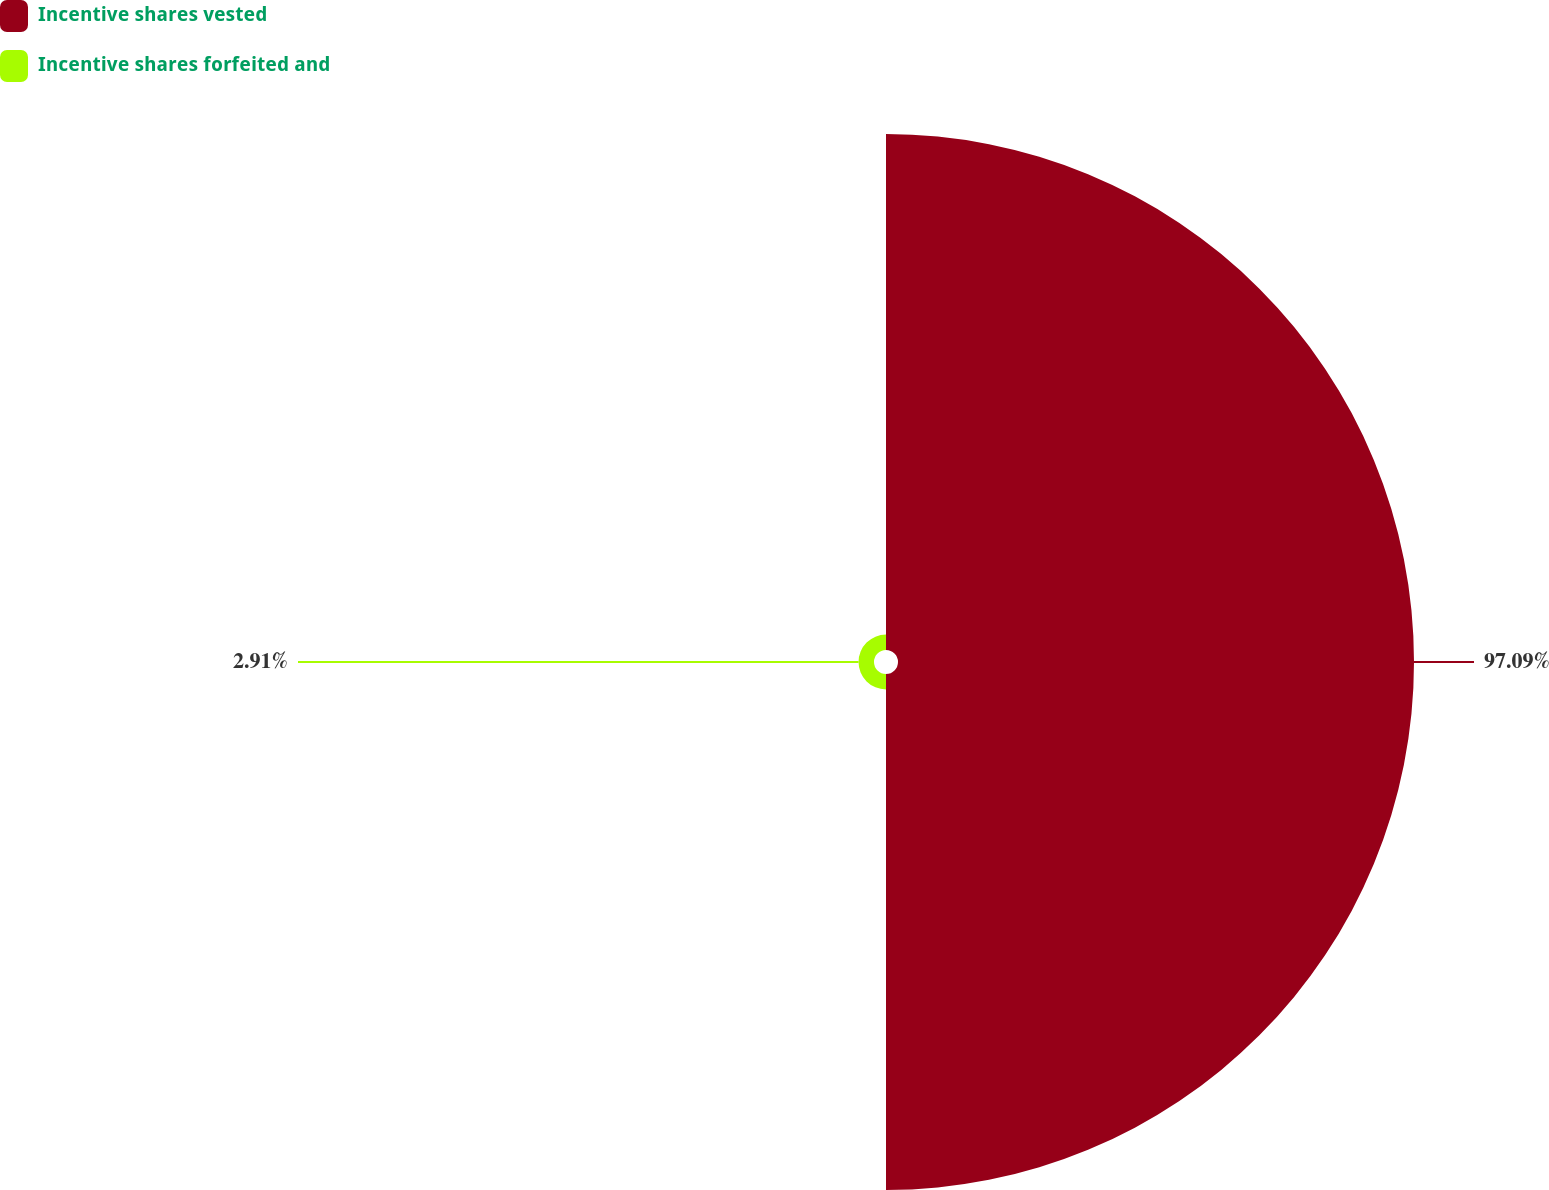<chart> <loc_0><loc_0><loc_500><loc_500><pie_chart><fcel>Incentive shares vested<fcel>Incentive shares forfeited and<nl><fcel>97.09%<fcel>2.91%<nl></chart> 